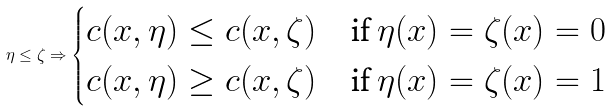Convert formula to latex. <formula><loc_0><loc_0><loc_500><loc_500>\eta \leq \zeta \Rightarrow \begin{cases} c ( x , \eta ) \leq c ( x , \zeta ) & \text {if $\eta(x)=\zeta(x)=0$} \\ c ( x , \eta ) \geq c ( x , \zeta ) & \text {if $\eta(x)=\zeta(x)=1$} \end{cases}</formula> 